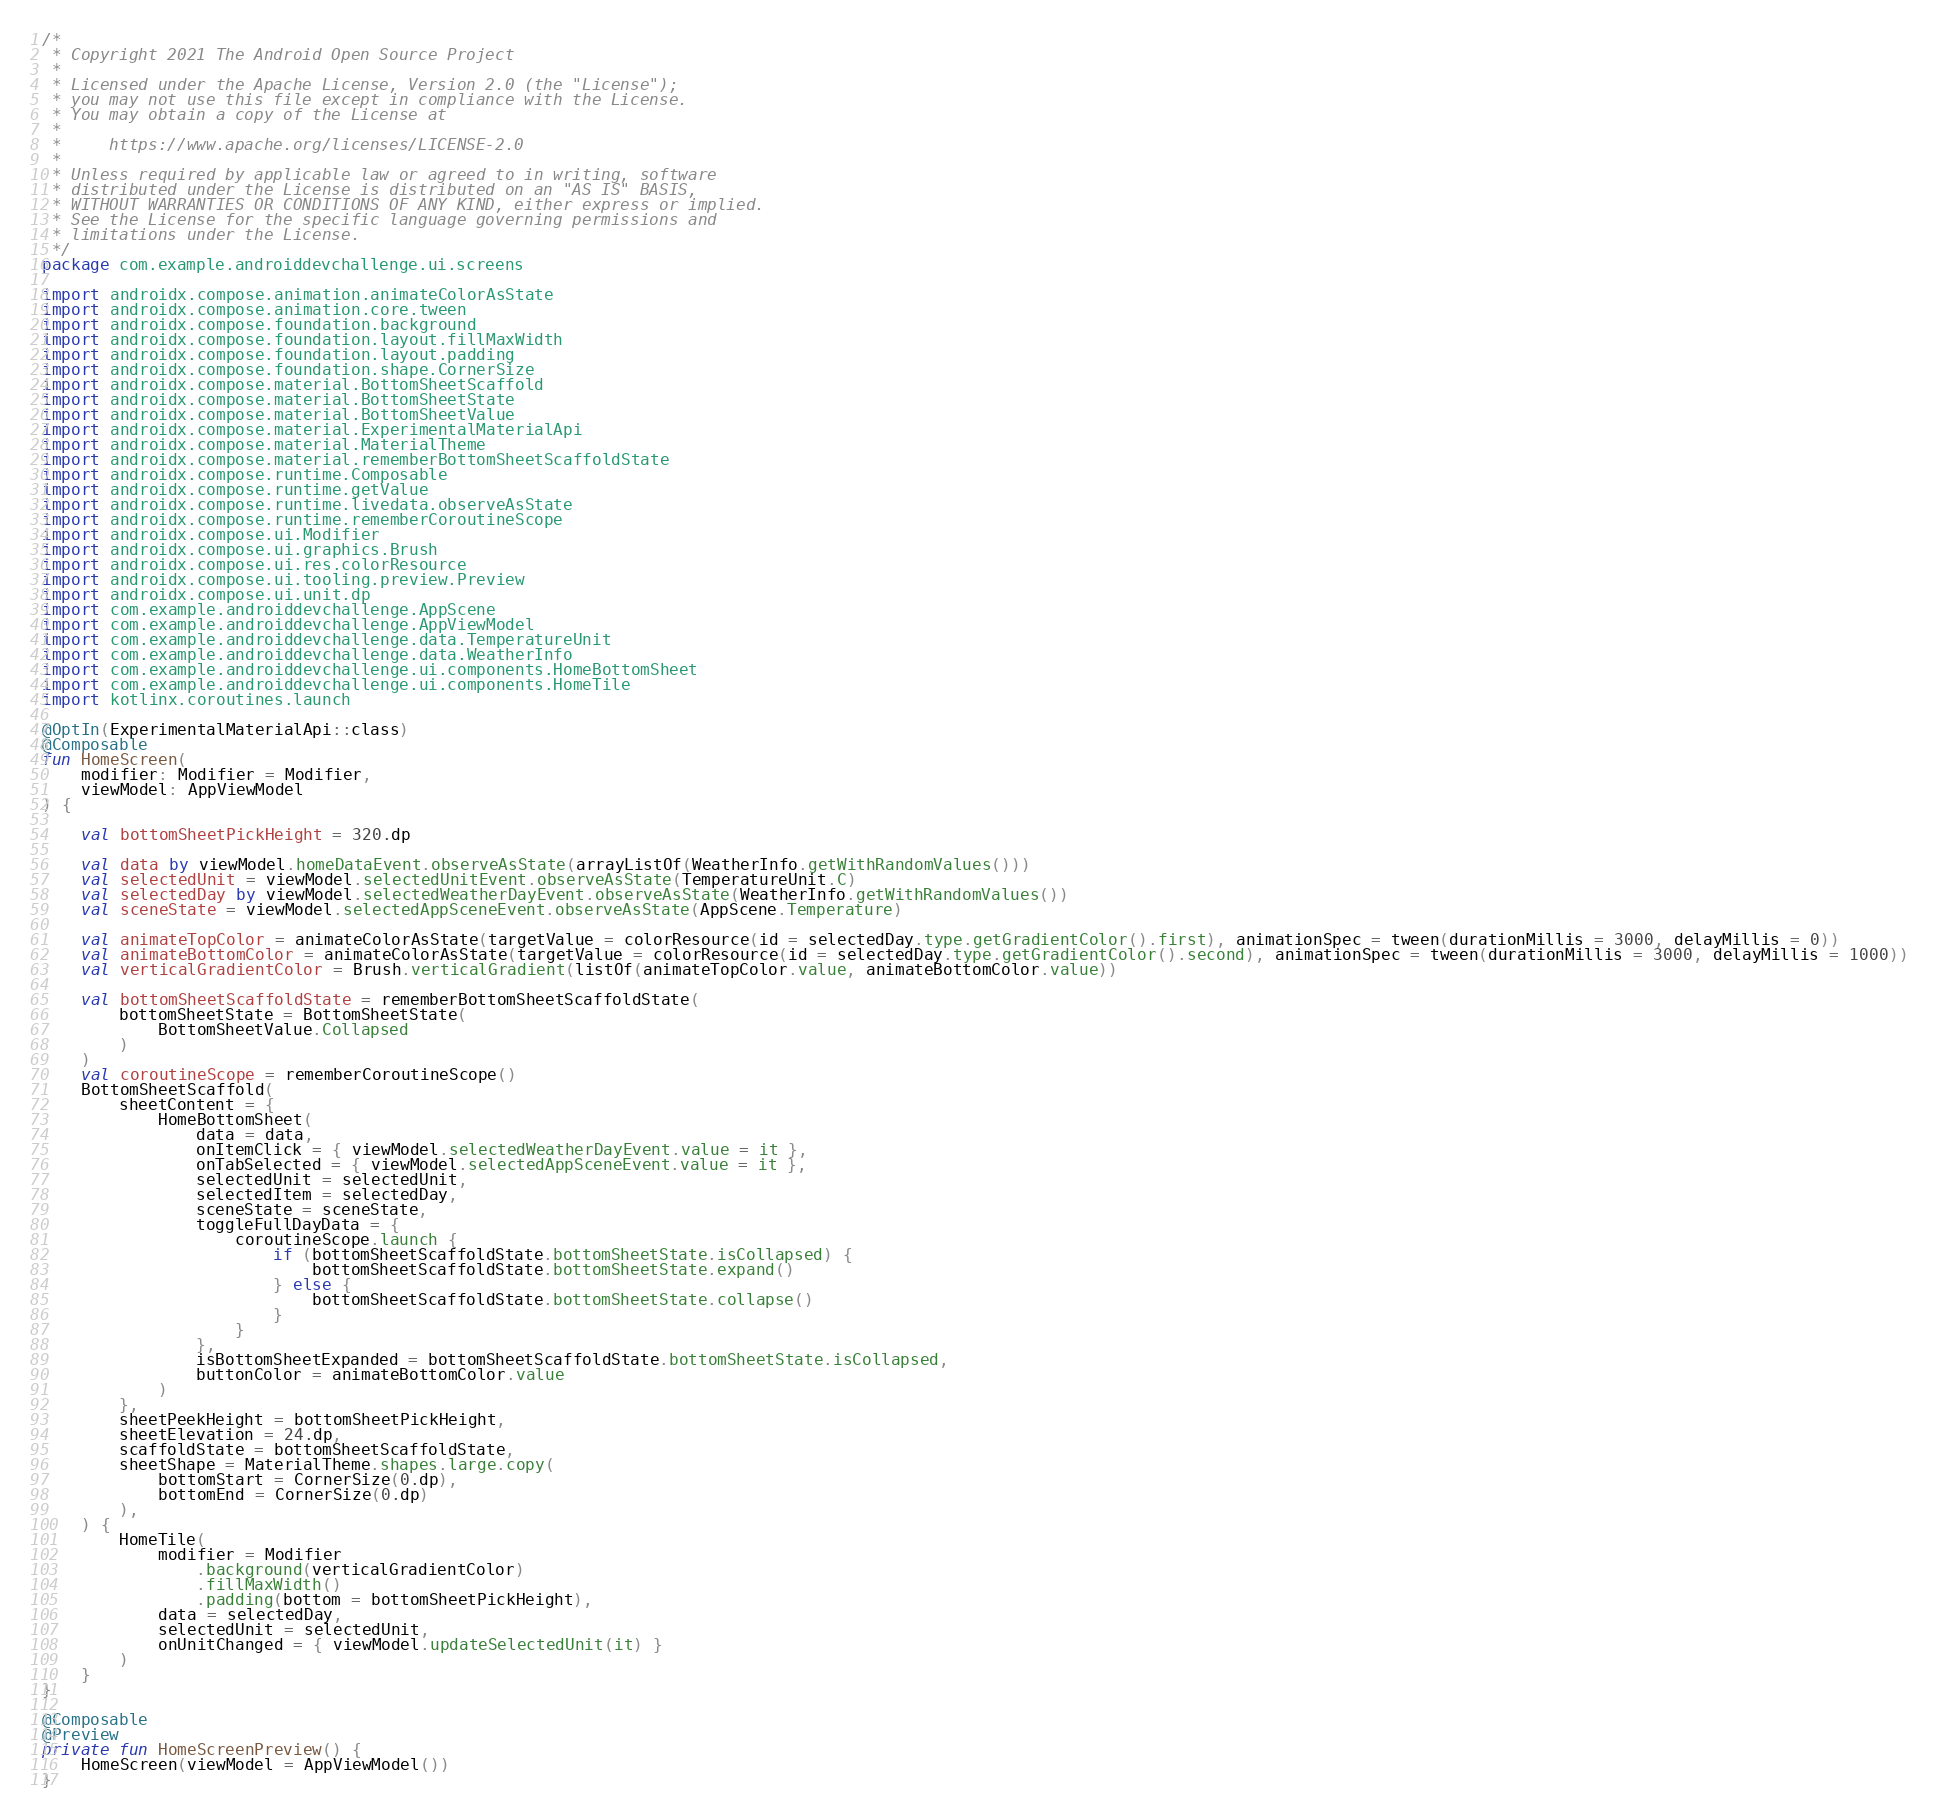Convert code to text. <code><loc_0><loc_0><loc_500><loc_500><_Kotlin_>/*
 * Copyright 2021 The Android Open Source Project
 *
 * Licensed under the Apache License, Version 2.0 (the "License");
 * you may not use this file except in compliance with the License.
 * You may obtain a copy of the License at
 *
 *     https://www.apache.org/licenses/LICENSE-2.0
 *
 * Unless required by applicable law or agreed to in writing, software
 * distributed under the License is distributed on an "AS IS" BASIS,
 * WITHOUT WARRANTIES OR CONDITIONS OF ANY KIND, either express or implied.
 * See the License for the specific language governing permissions and
 * limitations under the License.
 */
package com.example.androiddevchallenge.ui.screens

import androidx.compose.animation.animateColorAsState
import androidx.compose.animation.core.tween
import androidx.compose.foundation.background
import androidx.compose.foundation.layout.fillMaxWidth
import androidx.compose.foundation.layout.padding
import androidx.compose.foundation.shape.CornerSize
import androidx.compose.material.BottomSheetScaffold
import androidx.compose.material.BottomSheetState
import androidx.compose.material.BottomSheetValue
import androidx.compose.material.ExperimentalMaterialApi
import androidx.compose.material.MaterialTheme
import androidx.compose.material.rememberBottomSheetScaffoldState
import androidx.compose.runtime.Composable
import androidx.compose.runtime.getValue
import androidx.compose.runtime.livedata.observeAsState
import androidx.compose.runtime.rememberCoroutineScope
import androidx.compose.ui.Modifier
import androidx.compose.ui.graphics.Brush
import androidx.compose.ui.res.colorResource
import androidx.compose.ui.tooling.preview.Preview
import androidx.compose.ui.unit.dp
import com.example.androiddevchallenge.AppScene
import com.example.androiddevchallenge.AppViewModel
import com.example.androiddevchallenge.data.TemperatureUnit
import com.example.androiddevchallenge.data.WeatherInfo
import com.example.androiddevchallenge.ui.components.HomeBottomSheet
import com.example.androiddevchallenge.ui.components.HomeTile
import kotlinx.coroutines.launch

@OptIn(ExperimentalMaterialApi::class)
@Composable
fun HomeScreen(
    modifier: Modifier = Modifier,
    viewModel: AppViewModel
) {

    val bottomSheetPickHeight = 320.dp

    val data by viewModel.homeDataEvent.observeAsState(arrayListOf(WeatherInfo.getWithRandomValues()))
    val selectedUnit = viewModel.selectedUnitEvent.observeAsState(TemperatureUnit.C)
    val selectedDay by viewModel.selectedWeatherDayEvent.observeAsState(WeatherInfo.getWithRandomValues())
    val sceneState = viewModel.selectedAppSceneEvent.observeAsState(AppScene.Temperature)

    val animateTopColor = animateColorAsState(targetValue = colorResource(id = selectedDay.type.getGradientColor().first), animationSpec = tween(durationMillis = 3000, delayMillis = 0))
    val animateBottomColor = animateColorAsState(targetValue = colorResource(id = selectedDay.type.getGradientColor().second), animationSpec = tween(durationMillis = 3000, delayMillis = 1000))
    val verticalGradientColor = Brush.verticalGradient(listOf(animateTopColor.value, animateBottomColor.value))

    val bottomSheetScaffoldState = rememberBottomSheetScaffoldState(
        bottomSheetState = BottomSheetState(
            BottomSheetValue.Collapsed
        )
    )
    val coroutineScope = rememberCoroutineScope()
    BottomSheetScaffold(
        sheetContent = {
            HomeBottomSheet(
                data = data,
                onItemClick = { viewModel.selectedWeatherDayEvent.value = it },
                onTabSelected = { viewModel.selectedAppSceneEvent.value = it },
                selectedUnit = selectedUnit,
                selectedItem = selectedDay,
                sceneState = sceneState,
                toggleFullDayData = {
                    coroutineScope.launch {
                        if (bottomSheetScaffoldState.bottomSheetState.isCollapsed) {
                            bottomSheetScaffoldState.bottomSheetState.expand()
                        } else {
                            bottomSheetScaffoldState.bottomSheetState.collapse()
                        }
                    }
                },
                isBottomSheetExpanded = bottomSheetScaffoldState.bottomSheetState.isCollapsed,
                buttonColor = animateBottomColor.value
            )
        },
        sheetPeekHeight = bottomSheetPickHeight,
        sheetElevation = 24.dp,
        scaffoldState = bottomSheetScaffoldState,
        sheetShape = MaterialTheme.shapes.large.copy(
            bottomStart = CornerSize(0.dp),
            bottomEnd = CornerSize(0.dp)
        ),
    ) {
        HomeTile(
            modifier = Modifier
                .background(verticalGradientColor)
                .fillMaxWidth()
                .padding(bottom = bottomSheetPickHeight),
            data = selectedDay,
            selectedUnit = selectedUnit,
            onUnitChanged = { viewModel.updateSelectedUnit(it) }
        )
    }
}

@Composable
@Preview
private fun HomeScreenPreview() {
    HomeScreen(viewModel = AppViewModel())
}
</code> 